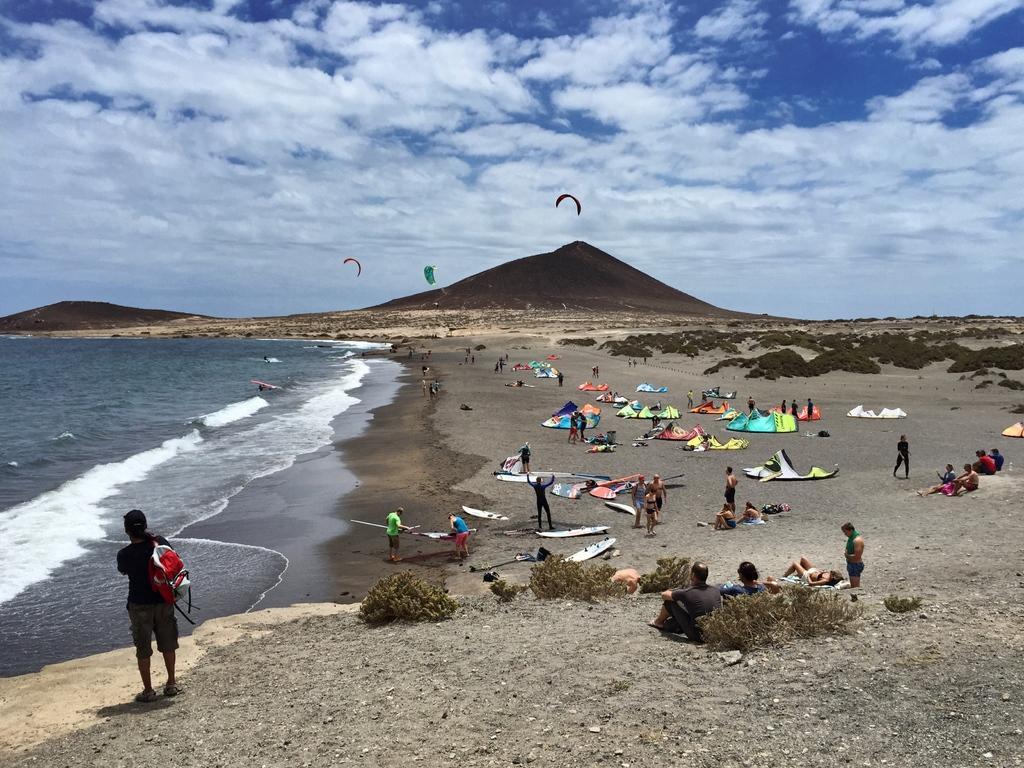Describe this image in one or two sentences. In this image I can see group of people, some are standing and some are sitting and I can also see few multicolor parachutes. Background I can see the water, mountains and the sky is in blue and white color. 